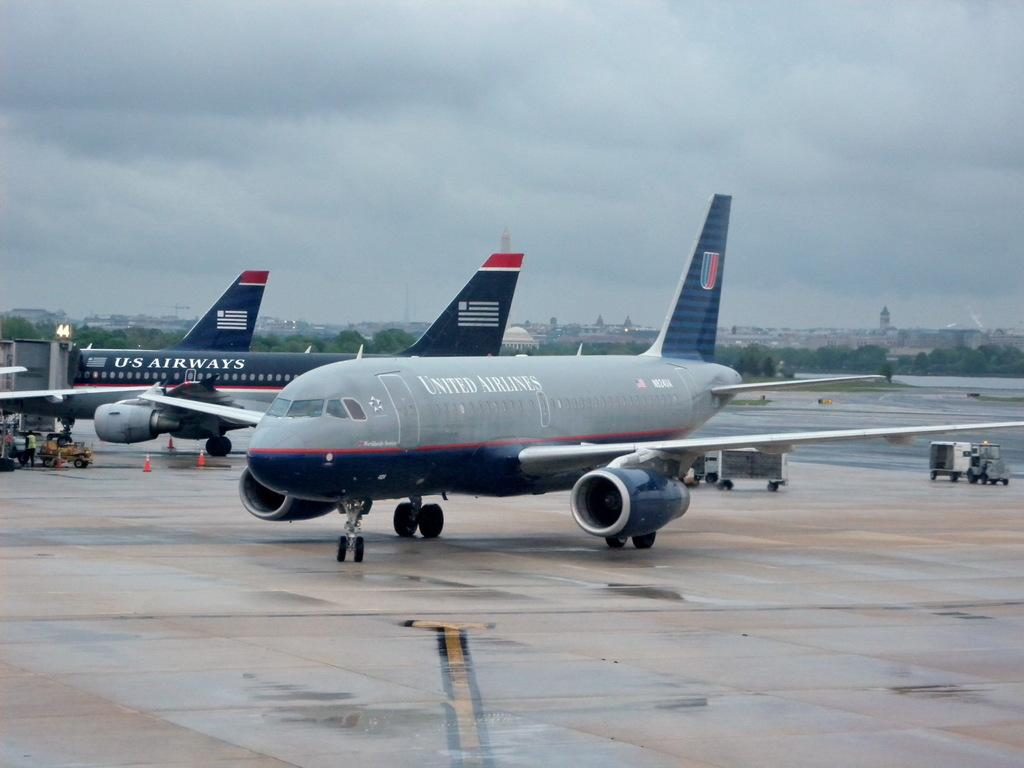Provide a one-sentence caption for the provided image. United Airlines Jet is parked on a cloudy rainy day. 